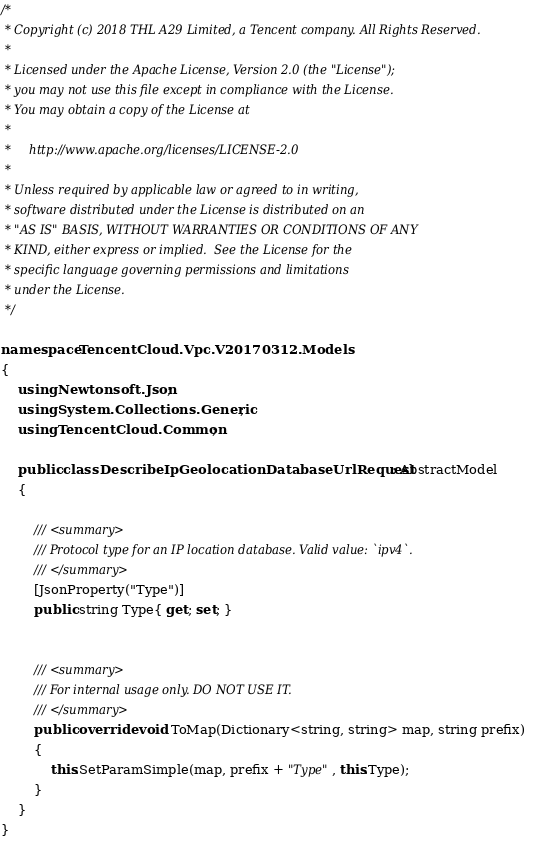Convert code to text. <code><loc_0><loc_0><loc_500><loc_500><_C#_>/*
 * Copyright (c) 2018 THL A29 Limited, a Tencent company. All Rights Reserved.
 *
 * Licensed under the Apache License, Version 2.0 (the "License");
 * you may not use this file except in compliance with the License.
 * You may obtain a copy of the License at
 *
 *     http://www.apache.org/licenses/LICENSE-2.0
 *
 * Unless required by applicable law or agreed to in writing,
 * software distributed under the License is distributed on an
 * "AS IS" BASIS, WITHOUT WARRANTIES OR CONDITIONS OF ANY
 * KIND, either express or implied.  See the License for the
 * specific language governing permissions and limitations
 * under the License.
 */

namespace TencentCloud.Vpc.V20170312.Models
{
    using Newtonsoft.Json;
    using System.Collections.Generic;
    using TencentCloud.Common;

    public class DescribeIpGeolocationDatabaseUrlRequest : AbstractModel
    {
        
        /// <summary>
        /// Protocol type for an IP location database. Valid value: `ipv4`.
        /// </summary>
        [JsonProperty("Type")]
        public string Type{ get; set; }


        /// <summary>
        /// For internal usage only. DO NOT USE IT.
        /// </summary>
        public override void ToMap(Dictionary<string, string> map, string prefix)
        {
            this.SetParamSimple(map, prefix + "Type", this.Type);
        }
    }
}

</code> 